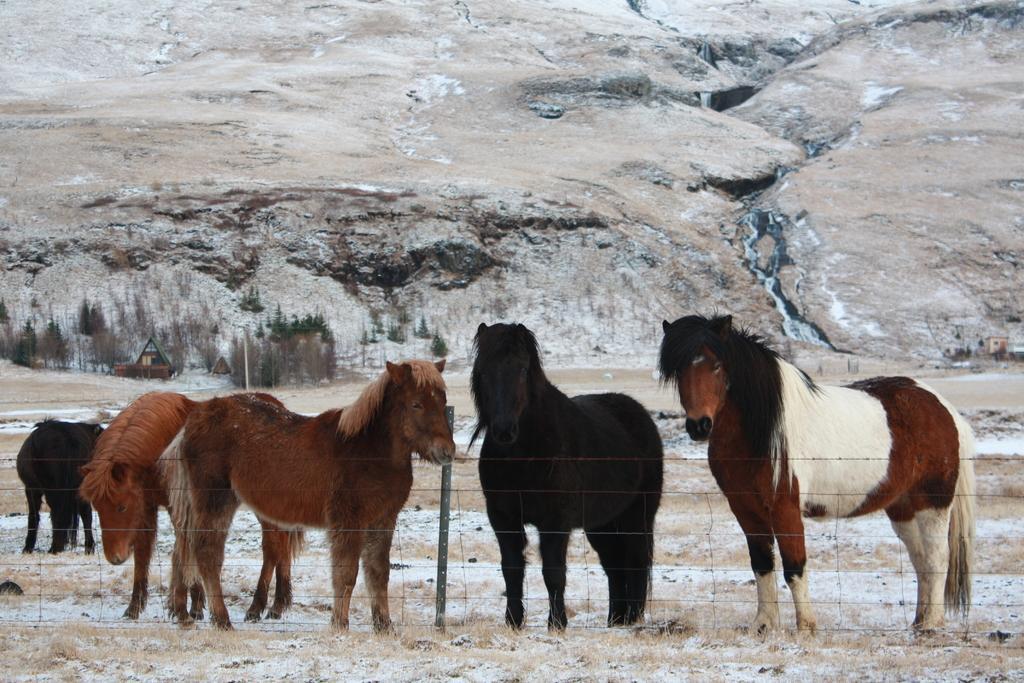Could you give a brief overview of what you see in this image? In the image we can see there are horses of different colors. Here we can see the snow, grass, trees and the mountain. Here we can see the fence and the pole. 